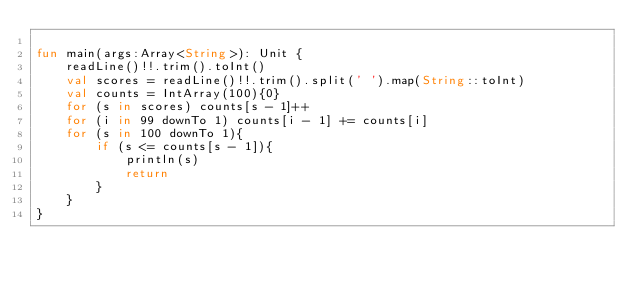<code> <loc_0><loc_0><loc_500><loc_500><_Kotlin_>
fun main(args:Array<String>): Unit {
    readLine()!!.trim().toInt()
    val scores = readLine()!!.trim().split(' ').map(String::toInt)
    val counts = IntArray(100){0}
    for (s in scores) counts[s - 1]++
    for (i in 99 downTo 1) counts[i - 1] += counts[i]
    for (s in 100 downTo 1){
        if (s <= counts[s - 1]){
            println(s)
            return
        }
    }
}
</code> 